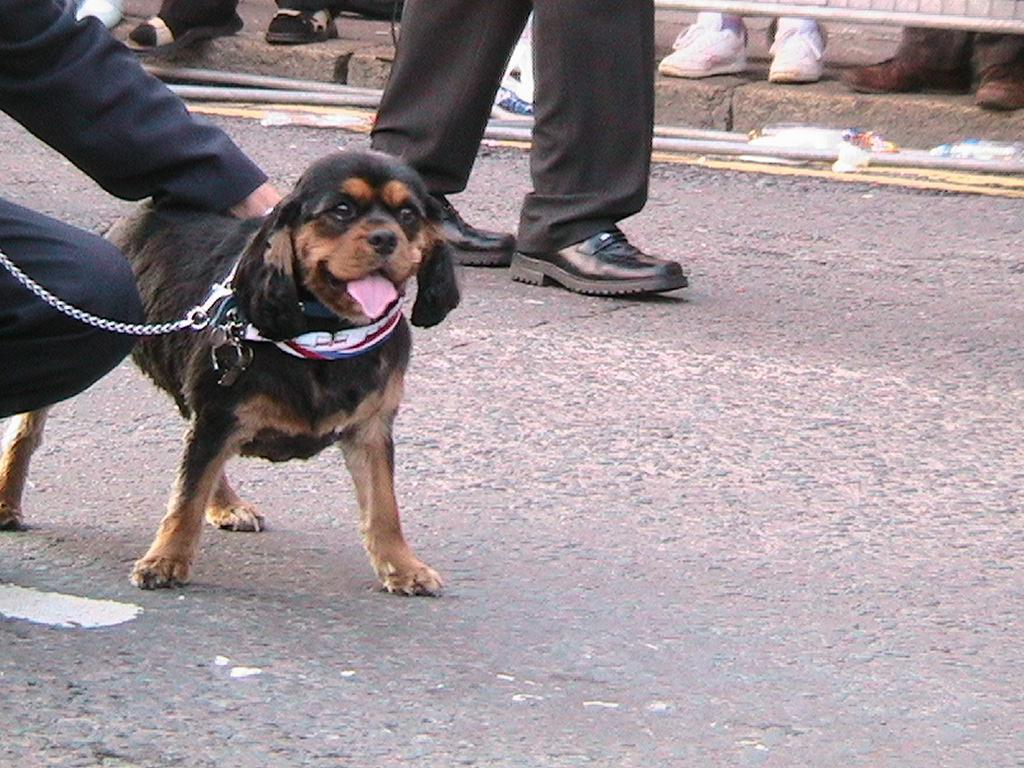What animal can be seen on the road in the image? There is a dog on the road in the image. What part of a human body is visible in the image? A human hand is visible in the image. What type of clothing item is present at the top of the image? There are footwear at the top of the image. What part of a human body is present in the image besides the hand? Human legs are present in the image. What type of infrastructure can be seen in the image? Pipes are visible in the image. What type of bells can be heard ringing in the image? There are no bells present in the image, and therefore no sound can be heard. What is the ground made of in the image? The ground is not described in the provided facts, so it cannot be determined from the image. 